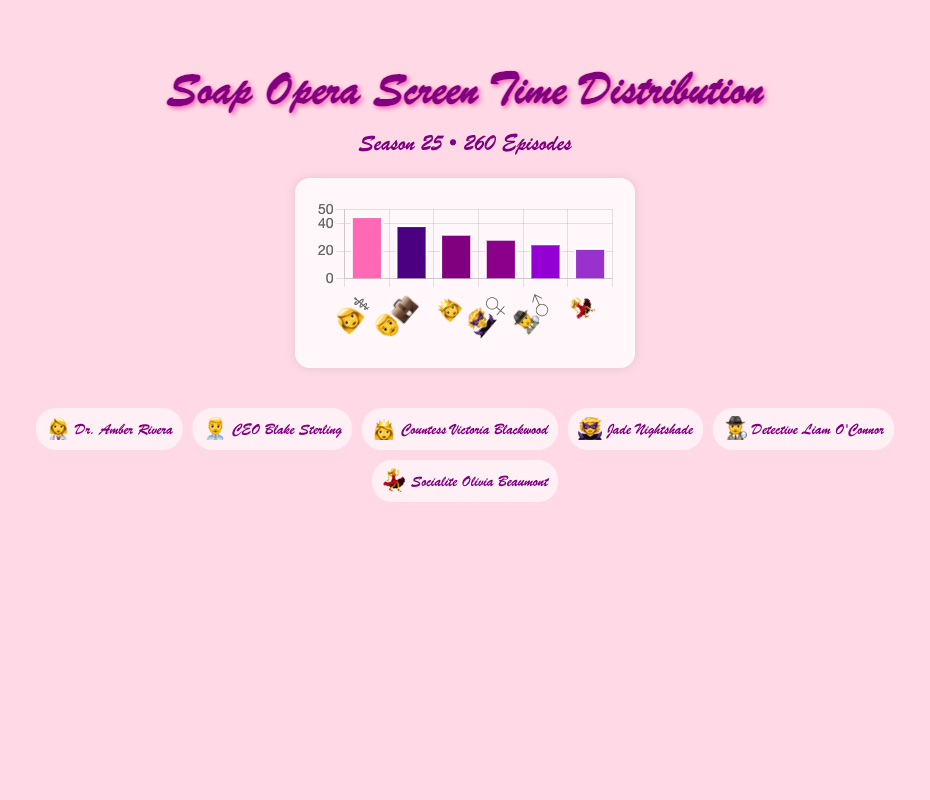What is the screen time percentage of Dr. Amber Rivera? Dr. Amber Rivera's emoji (👩‍⚕️) represents her screen time percentage. The figure shows her screen time as 45.2%.
Answer: 45.2% Which character has the least screen time percentage? The figure displays screen time percentages using emojis. By scanning the bar lengths, Socialite Olivia Beaumont (💃) has the shortest bar, representing 22.3%.
Answer: 💃 How much more screen time does Dr. Amber Rivera have compared to Socialite Olivia Beaumont? Dr. Amber Rivera's screen time is 45.2% and Socialite Olivia Beaumont's screen time is 22.3%. Subtracting these values gives 45.2 - 22.3 = 22.9.
Answer: 22.9% Who has more screen time: Countess Victoria Blackwood or Jade Nightshade? Comparing their bars, Countess Victoria Blackwood (👸) has a screen time of 32.5%, which is greater than Jade Nightshade's (🦹‍♀️) 28.9%.
Answer: 👸 What's the combined screen time percentage of CEO Blake Sterling and Detective Liam O'Connor? Adding their screen times, CEO Blake Sterling has 38.7% and Detective Liam O'Connor has 25.6%. The combined total is 38.7 + 25.6 = 64.3%.
Answer: 64.3% Which two characters have the most similar screen time percentages? Examining the bars, Jade Nightshade (28.9%) and Detective Liam O'Connor (25.6%) have the closest screen time percentages, with a difference of 3.3%.
Answer: 🦹‍♀️ and 🕵️‍♂️ How many characters have a screen time percentage higher than 30%? Characters with more than 30% screen time can be identified by their bar lengths. Dr. Amber Rivera (45.2%), CEO Blake Sterling (38.7%), and Countess Victoria Blackwood (32.5%) are those characters.
Answer: 3 What is the difference in screen time percentage between the characters with the highest and lowest screen time? Dr. Amber Rivera has the highest screen time percentage at 45.2%, and Socialite Olivia Beaumont has the lowest at 22.3%. The difference is 45.2 - 22.3 = 22.9%.
Answer: 22.9% By how much does CEO Blake Sterling's screen time exceed Countess Victoria Blackwood's? CEO Blake Sterling's screen time is 38.7%, and Countess Victoria Blackwood's is 32.5%. The difference is 38.7 - 32.5 = 6.2.
Answer: 6.2 What's the average screen time percentage of all main characters? Summing the screen times of all characters: 45.2 + 38.7 + 32.5 + 28.9 + 25.6 + 22.3 = 193.2. There are 6 characters, so the average is 193.2 / 6 ≈ 32.2.
Answer: 32.2% 